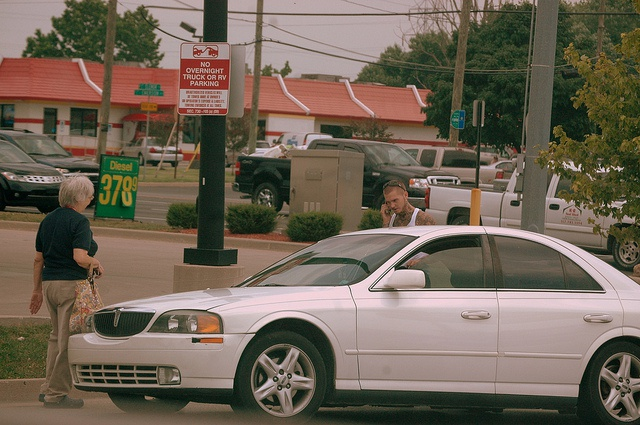Describe the objects in this image and their specific colors. I can see car in gray, darkgray, black, and lightgray tones, people in gray, black, and maroon tones, truck in gray, darkgray, and black tones, truck in gray, black, darkgreen, and darkgray tones, and car in gray, black, and darkgreen tones in this image. 